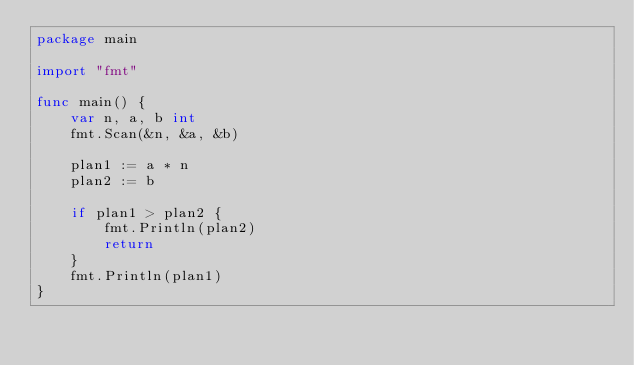<code> <loc_0><loc_0><loc_500><loc_500><_Go_>package main

import "fmt"

func main() {
	var n, a, b int
	fmt.Scan(&n, &a, &b)

	plan1 := a * n
	plan2 := b

	if plan1 > plan2 {
		fmt.Println(plan2)
		return
	}
	fmt.Println(plan1)
}
</code> 